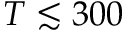<formula> <loc_0><loc_0><loc_500><loc_500>T \lesssim 3 0 0</formula> 